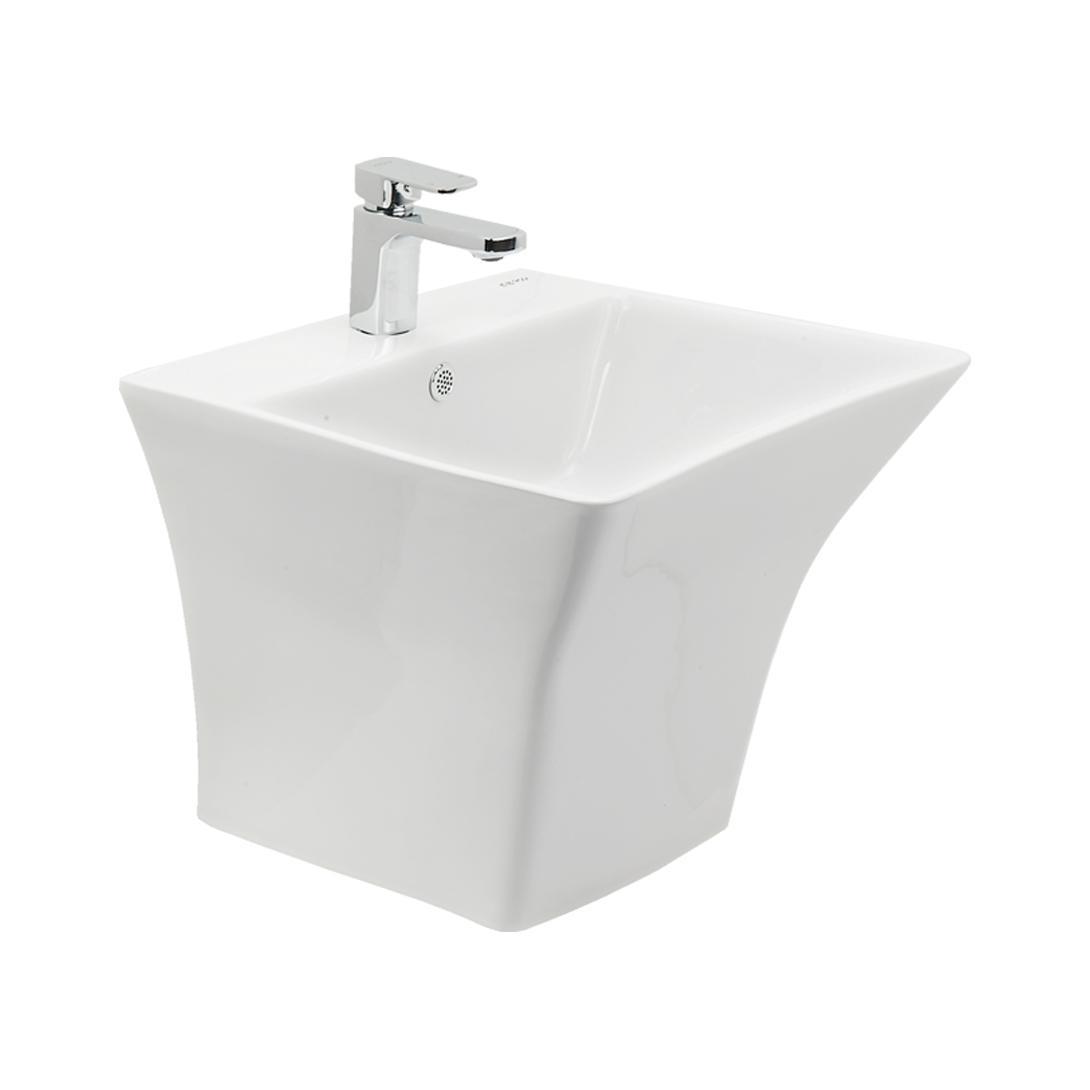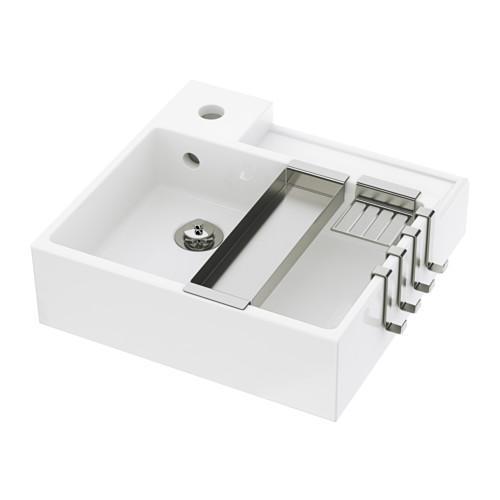The first image is the image on the left, the second image is the image on the right. Analyze the images presented: Is the assertion "The right-hand sink is rectangular rather than rounded." valid? Answer yes or no. Yes. 